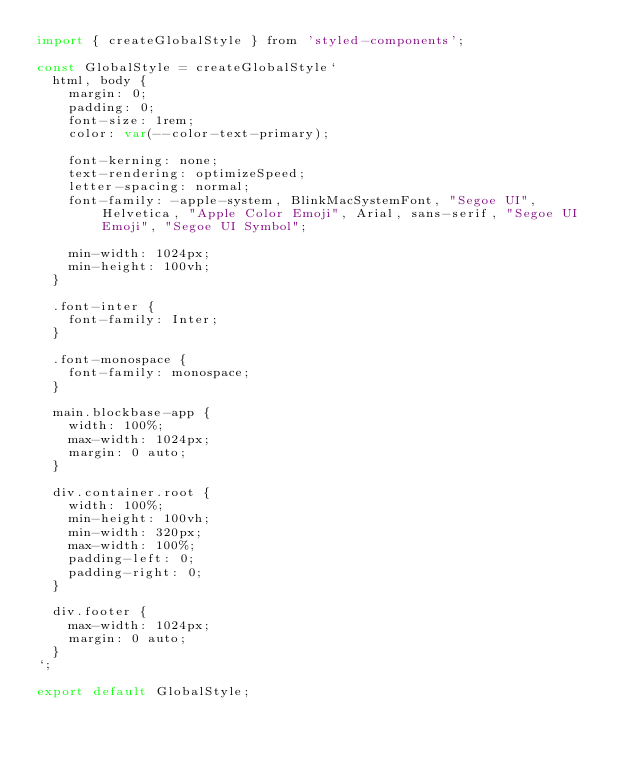Convert code to text. <code><loc_0><loc_0><loc_500><loc_500><_JavaScript_>import { createGlobalStyle } from 'styled-components';

const GlobalStyle = createGlobalStyle`
  html, body {
    margin: 0;
    padding: 0;
    font-size: 1rem;
    color: var(--color-text-primary);

    font-kerning: none;
    text-rendering: optimizeSpeed;
    letter-spacing: normal;
    font-family: -apple-system, BlinkMacSystemFont, "Segoe UI", Helvetica, "Apple Color Emoji", Arial, sans-serif, "Segoe UI Emoji", "Segoe UI Symbol";

    min-width: 1024px;
    min-height: 100vh;
  }

  .font-inter {
    font-family: Inter;
  }

  .font-monospace {
    font-family: monospace;
  }

  main.blockbase-app {
    width: 100%;
    max-width: 1024px;
    margin: 0 auto;
  }

  div.container.root {
    width: 100%;
    min-height: 100vh;
    min-width: 320px;
    max-width: 100%;
    padding-left: 0;
    padding-right: 0;
  }

  div.footer {
    max-width: 1024px;
    margin: 0 auto;
  }
`;
 
export default GlobalStyle;</code> 